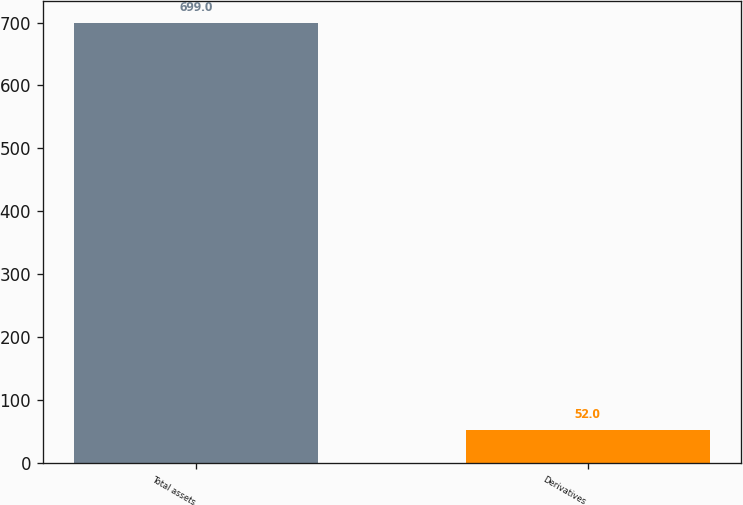Convert chart to OTSL. <chart><loc_0><loc_0><loc_500><loc_500><bar_chart><fcel>Total assets<fcel>Derivatives<nl><fcel>699<fcel>52<nl></chart> 